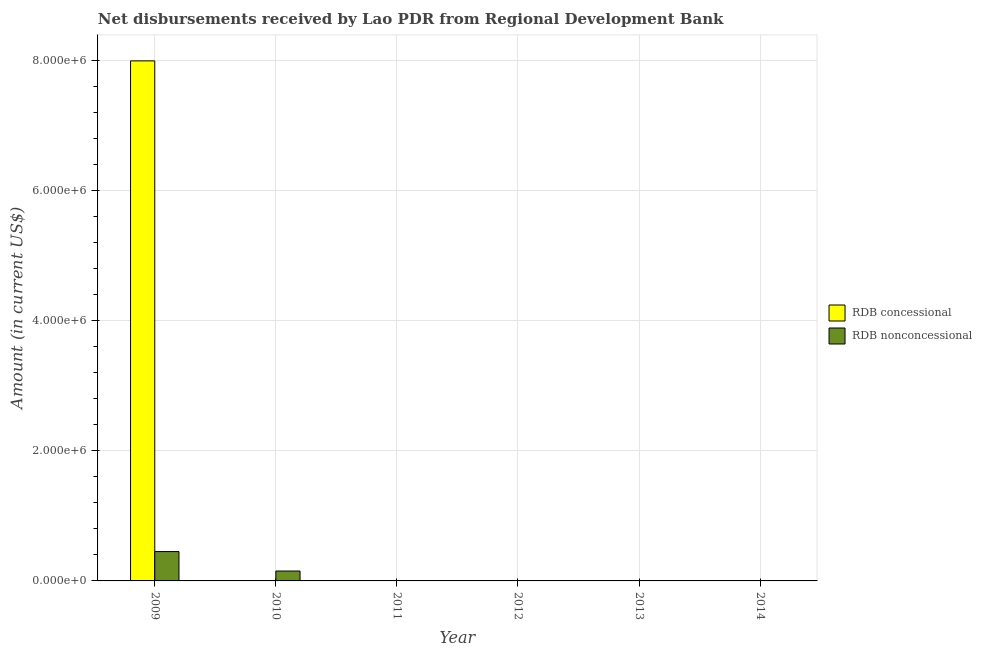How many different coloured bars are there?
Ensure brevity in your answer.  2. In how many cases, is the number of bars for a given year not equal to the number of legend labels?
Make the answer very short. 5. Across all years, what is the maximum net non concessional disbursements from rdb?
Give a very brief answer. 4.51e+05. Across all years, what is the minimum net concessional disbursements from rdb?
Your answer should be compact. 0. What is the total net non concessional disbursements from rdb in the graph?
Your answer should be very brief. 6.03e+05. What is the average net concessional disbursements from rdb per year?
Your answer should be compact. 1.33e+06. What is the ratio of the net non concessional disbursements from rdb in 2009 to that in 2010?
Your response must be concise. 2.97. Is the net non concessional disbursements from rdb in 2009 less than that in 2010?
Provide a short and direct response. No. What is the difference between the highest and the lowest net non concessional disbursements from rdb?
Give a very brief answer. 4.51e+05. In how many years, is the net non concessional disbursements from rdb greater than the average net non concessional disbursements from rdb taken over all years?
Offer a very short reply. 2. How many years are there in the graph?
Make the answer very short. 6. Does the graph contain any zero values?
Ensure brevity in your answer.  Yes. Does the graph contain grids?
Make the answer very short. Yes. Where does the legend appear in the graph?
Make the answer very short. Center right. How many legend labels are there?
Provide a succinct answer. 2. What is the title of the graph?
Ensure brevity in your answer.  Net disbursements received by Lao PDR from Regional Development Bank. Does "Largest city" appear as one of the legend labels in the graph?
Provide a succinct answer. No. What is the label or title of the X-axis?
Your response must be concise. Year. What is the label or title of the Y-axis?
Ensure brevity in your answer.  Amount (in current US$). What is the Amount (in current US$) in RDB concessional in 2009?
Provide a short and direct response. 7.99e+06. What is the Amount (in current US$) in RDB nonconcessional in 2009?
Ensure brevity in your answer.  4.51e+05. What is the Amount (in current US$) of RDB concessional in 2010?
Your answer should be compact. 0. What is the Amount (in current US$) of RDB nonconcessional in 2010?
Provide a short and direct response. 1.52e+05. What is the Amount (in current US$) of RDB concessional in 2011?
Your response must be concise. 0. What is the Amount (in current US$) of RDB nonconcessional in 2012?
Provide a short and direct response. 0. Across all years, what is the maximum Amount (in current US$) in RDB concessional?
Provide a short and direct response. 7.99e+06. Across all years, what is the maximum Amount (in current US$) of RDB nonconcessional?
Make the answer very short. 4.51e+05. Across all years, what is the minimum Amount (in current US$) in RDB nonconcessional?
Provide a succinct answer. 0. What is the total Amount (in current US$) of RDB concessional in the graph?
Your answer should be compact. 7.99e+06. What is the total Amount (in current US$) of RDB nonconcessional in the graph?
Offer a very short reply. 6.03e+05. What is the difference between the Amount (in current US$) in RDB nonconcessional in 2009 and that in 2010?
Ensure brevity in your answer.  2.99e+05. What is the difference between the Amount (in current US$) of RDB concessional in 2009 and the Amount (in current US$) of RDB nonconcessional in 2010?
Ensure brevity in your answer.  7.84e+06. What is the average Amount (in current US$) of RDB concessional per year?
Provide a short and direct response. 1.33e+06. What is the average Amount (in current US$) in RDB nonconcessional per year?
Ensure brevity in your answer.  1.00e+05. In the year 2009, what is the difference between the Amount (in current US$) of RDB concessional and Amount (in current US$) of RDB nonconcessional?
Your answer should be very brief. 7.54e+06. What is the ratio of the Amount (in current US$) in RDB nonconcessional in 2009 to that in 2010?
Keep it short and to the point. 2.97. What is the difference between the highest and the lowest Amount (in current US$) in RDB concessional?
Provide a succinct answer. 7.99e+06. What is the difference between the highest and the lowest Amount (in current US$) in RDB nonconcessional?
Give a very brief answer. 4.51e+05. 